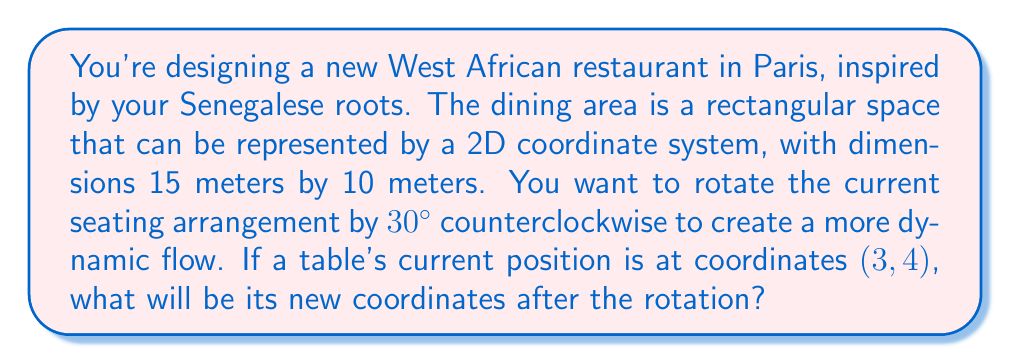Provide a solution to this math problem. To solve this problem, we'll use a linear transformation for rotation. The steps are as follows:

1) The rotation matrix for a counterclockwise rotation by θ degrees is:

   $$R = \begin{bmatrix} 
   \cos θ & -\sin θ \\
   \sin θ & \cos θ
   \end{bmatrix}$$

2) For a 30° rotation, θ = 30°. Let's calculate the sine and cosine:
   
   $\cos 30° = \frac{\sqrt{3}}{2}$ and $\sin 30° = \frac{1}{2}$

3) Substituting these values into the rotation matrix:

   $$R = \begin{bmatrix} 
   \frac{\sqrt{3}}{2} & -\frac{1}{2} \\
   \frac{1}{2} & \frac{\sqrt{3}}{2}
   \end{bmatrix}$$

4) The original coordinates of the table are (3, 4). We can represent this as a column vector:

   $$\vec{v} = \begin{bmatrix} 
   3 \\
   4
   \end{bmatrix}$$

5) To find the new coordinates, we multiply the rotation matrix by the coordinate vector:

   $$R\vec{v} = \begin{bmatrix} 
   \frac{\sqrt{3}}{2} & -\frac{1}{2} \\
   \frac{1}{2} & \frac{\sqrt{3}}{2}
   \end{bmatrix} \begin{bmatrix} 
   3 \\
   4
   \end{bmatrix}$$

6) Performing the matrix multiplication:

   $$\begin{bmatrix} 
   \frac{\sqrt{3}}{2}(3) - \frac{1}{2}(4) \\
   \frac{1}{2}(3) + \frac{\sqrt{3}}{2}(4)
   \end{bmatrix} = \begin{bmatrix} 
   \frac{3\sqrt{3}}{2} - 2 \\
   \frac{3}{2} + 2\sqrt{3}
   \end{bmatrix}$$

7) Simplifying:

   $$\begin{bmatrix} 
   \frac{3\sqrt{3} - 4}{2} \\
   \frac{3 + 4\sqrt{3}}{2}
   \end{bmatrix}$$

Therefore, the new coordinates of the table after rotation are $(\frac{3\sqrt{3} - 4}{2}, \frac{3 + 4\sqrt{3}}{2})$.
Answer: $(\frac{3\sqrt{3} - 4}{2}, \frac{3 + 4\sqrt{3}}{2})$ 